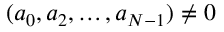<formula> <loc_0><loc_0><loc_500><loc_500>( a _ { 0 } , a _ { 2 } , \dots , a _ { N - 1 } ) \neq 0</formula> 